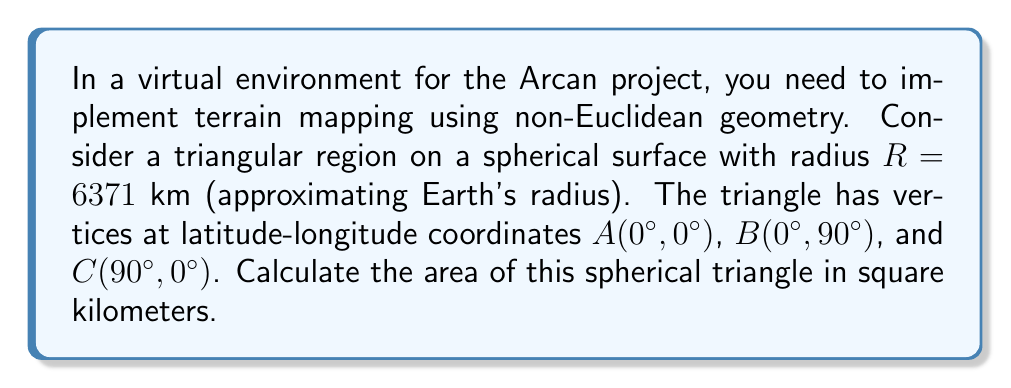What is the answer to this math problem? To solve this problem, we'll use the formula for the area of a spherical triangle:

$$A = R^2 \cdot E$$

Where $A$ is the area, $R$ is the radius of the sphere, and $E$ is the spherical excess in radians.

Steps:
1) First, we need to calculate the angles of the spherical triangle. Given the coordinates, we can see that this forms a right-angled triangle on the sphere's surface.

2) The angle at vertex $A$ is 90°, as it's at the intersection of the equator and prime meridian.

3) The angles at vertices $B$ and $C$ are both 90° due to the nature of great circles on a sphere.

4) The spherical excess $E$ is calculated as:

   $$E = (A + B + C) - \pi$$
   
   Where $A$, $B$, and $C$ are the angles in radians.

5) Converting our angles to radians:
   $$90° = \frac{\pi}{2} \text{ radians}$$

6) Calculating the spherical excess:
   $$E = (\frac{\pi}{2} + \frac{\pi}{2} + \frac{\pi}{2}) - \pi = \frac{\pi}{2}$$

7) Now we can apply the area formula:
   $$A = R^2 \cdot E = (6371)^2 \cdot \frac{\pi}{2} \approx 63,782,739.7 \text{ km}^2$$

[asy]
import geometry;

size(200);
pair O=(0,0);
real R=5;
draw(circle(O,R));
pair A=R*dir(0);
pair B=R*dir(90);
pair C=R*dir(180);
draw(A--B--C--cycle);
dot("A",A,E);
dot("B",B,N);
dot("C",C,W);
label("Spherical Triangle",O,S);
[/asy]
Answer: $63,782,739.7 \text{ km}^2$ 